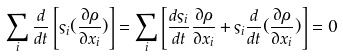<formula> <loc_0><loc_0><loc_500><loc_500>\sum _ { i } \frac { d } { d t } \left [ \varsigma _ { i } ( \frac { \partial \rho } { \partial x _ { i } } ) \right ] = \sum _ { i } \left [ \frac { d \varsigma _ { i } } { d t } \frac { \partial \rho } { \partial x _ { i } } + \varsigma _ { i } \frac { d } { d t } ( \frac { \partial \rho } { \partial x _ { i } } ) \right ] = 0</formula> 